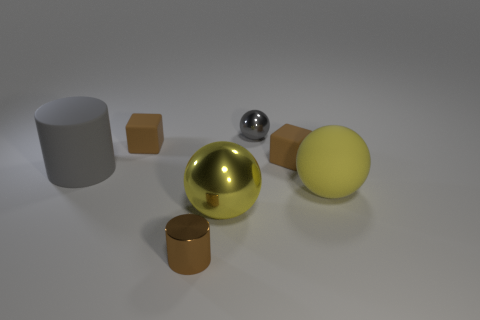What number of other objects are the same material as the gray ball?
Your answer should be compact. 2. How many metal things are either gray balls or small red cylinders?
Make the answer very short. 1. There is a big yellow shiny thing in front of the small gray sphere; is its shape the same as the small gray thing?
Offer a very short reply. Yes. Are there more matte cubes right of the tiny cylinder than big yellow matte blocks?
Offer a very short reply. Yes. What number of things are both on the right side of the large gray object and left of the tiny cylinder?
Provide a succinct answer. 1. There is a tiny metal thing that is behind the rubber block to the right of the gray ball; what color is it?
Give a very brief answer. Gray. What number of large shiny spheres are the same color as the matte sphere?
Make the answer very short. 1. Is the color of the small cylinder the same as the tiny matte cube that is to the left of the brown cylinder?
Make the answer very short. Yes. Is the number of brown cylinders less than the number of small brown matte objects?
Your response must be concise. Yes. Is the number of small cylinders that are behind the brown shiny cylinder greater than the number of big spheres on the right side of the small gray shiny sphere?
Offer a very short reply. No. 